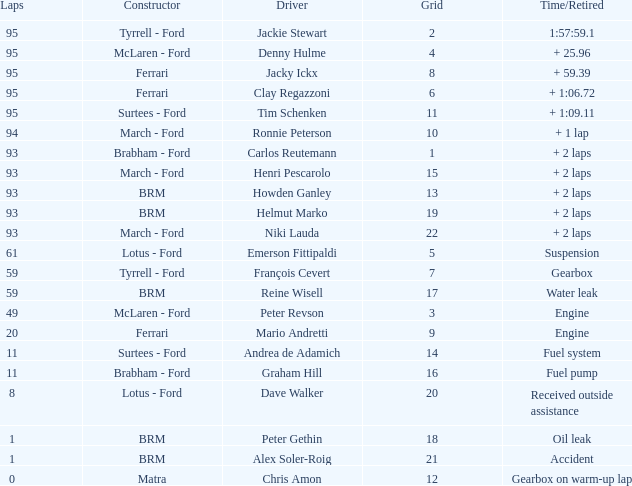What is the largest number of laps with a Grid larger than 14, a Time/Retired of + 2 laps, and a Driver of helmut marko? 93.0. 